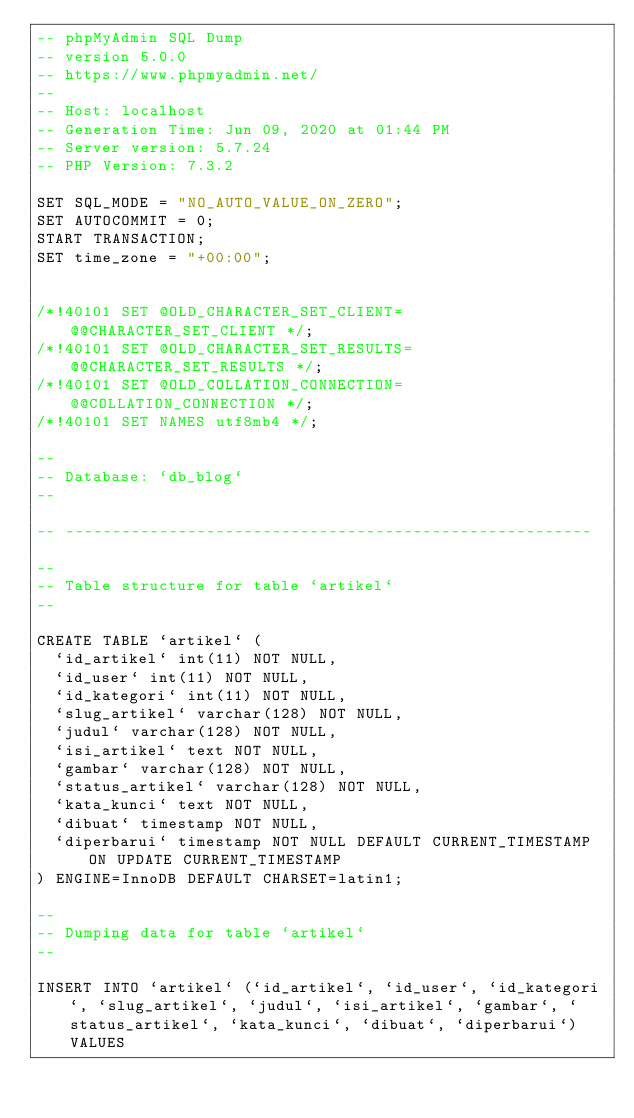<code> <loc_0><loc_0><loc_500><loc_500><_SQL_>-- phpMyAdmin SQL Dump
-- version 5.0.0
-- https://www.phpmyadmin.net/
--
-- Host: localhost
-- Generation Time: Jun 09, 2020 at 01:44 PM
-- Server version: 5.7.24
-- PHP Version: 7.3.2

SET SQL_MODE = "NO_AUTO_VALUE_ON_ZERO";
SET AUTOCOMMIT = 0;
START TRANSACTION;
SET time_zone = "+00:00";


/*!40101 SET @OLD_CHARACTER_SET_CLIENT=@@CHARACTER_SET_CLIENT */;
/*!40101 SET @OLD_CHARACTER_SET_RESULTS=@@CHARACTER_SET_RESULTS */;
/*!40101 SET @OLD_COLLATION_CONNECTION=@@COLLATION_CONNECTION */;
/*!40101 SET NAMES utf8mb4 */;

--
-- Database: `db_blog`
--

-- --------------------------------------------------------

--
-- Table structure for table `artikel`
--

CREATE TABLE `artikel` (
  `id_artikel` int(11) NOT NULL,
  `id_user` int(11) NOT NULL,
  `id_kategori` int(11) NOT NULL,
  `slug_artikel` varchar(128) NOT NULL,
  `judul` varchar(128) NOT NULL,
  `isi_artikel` text NOT NULL,
  `gambar` varchar(128) NOT NULL,
  `status_artikel` varchar(128) NOT NULL,
  `kata_kunci` text NOT NULL,
  `dibuat` timestamp NOT NULL,
  `diperbarui` timestamp NOT NULL DEFAULT CURRENT_TIMESTAMP ON UPDATE CURRENT_TIMESTAMP
) ENGINE=InnoDB DEFAULT CHARSET=latin1;

--
-- Dumping data for table `artikel`
--

INSERT INTO `artikel` (`id_artikel`, `id_user`, `id_kategori`, `slug_artikel`, `judul`, `isi_artikel`, `gambar`, `status_artikel`, `kata_kunci`, `dibuat`, `diperbarui`) VALUES</code> 